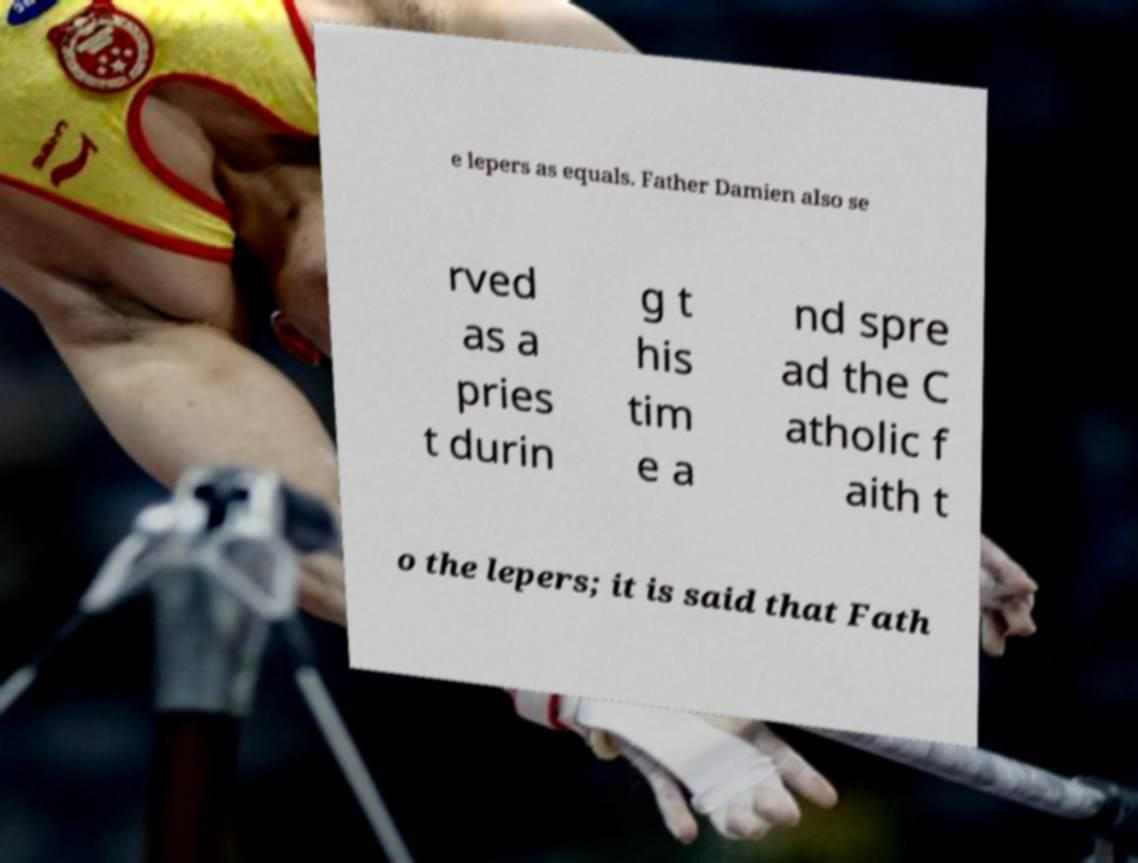Can you accurately transcribe the text from the provided image for me? e lepers as equals. Father Damien also se rved as a pries t durin g t his tim e a nd spre ad the C atholic f aith t o the lepers; it is said that Fath 